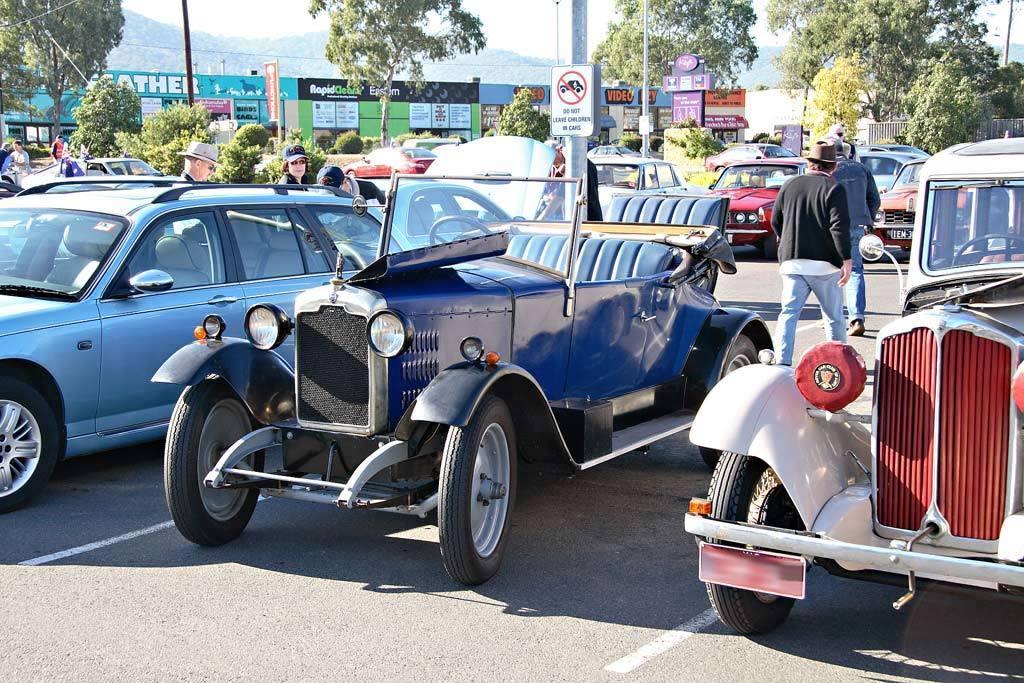Describe this image in one or two sentences. In the image there are different types of cars parked on the road and around the cars there are few people and behind the cars there are some plants and trees and in the background there are few stores, behind the stores there are mountains. 